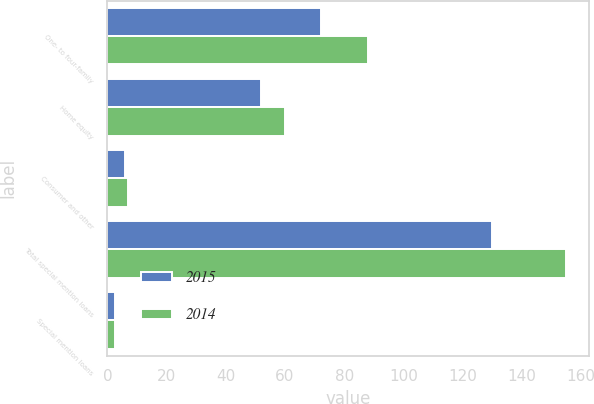<chart> <loc_0><loc_0><loc_500><loc_500><stacked_bar_chart><ecel><fcel>One- to four-family<fcel>Home equity<fcel>Consumer and other<fcel>Total special mention loans<fcel>Special mention loans<nl><fcel>2015<fcel>72<fcel>52<fcel>6<fcel>130<fcel>2.6<nl><fcel>2014<fcel>88<fcel>60<fcel>7<fcel>155<fcel>2.4<nl></chart> 